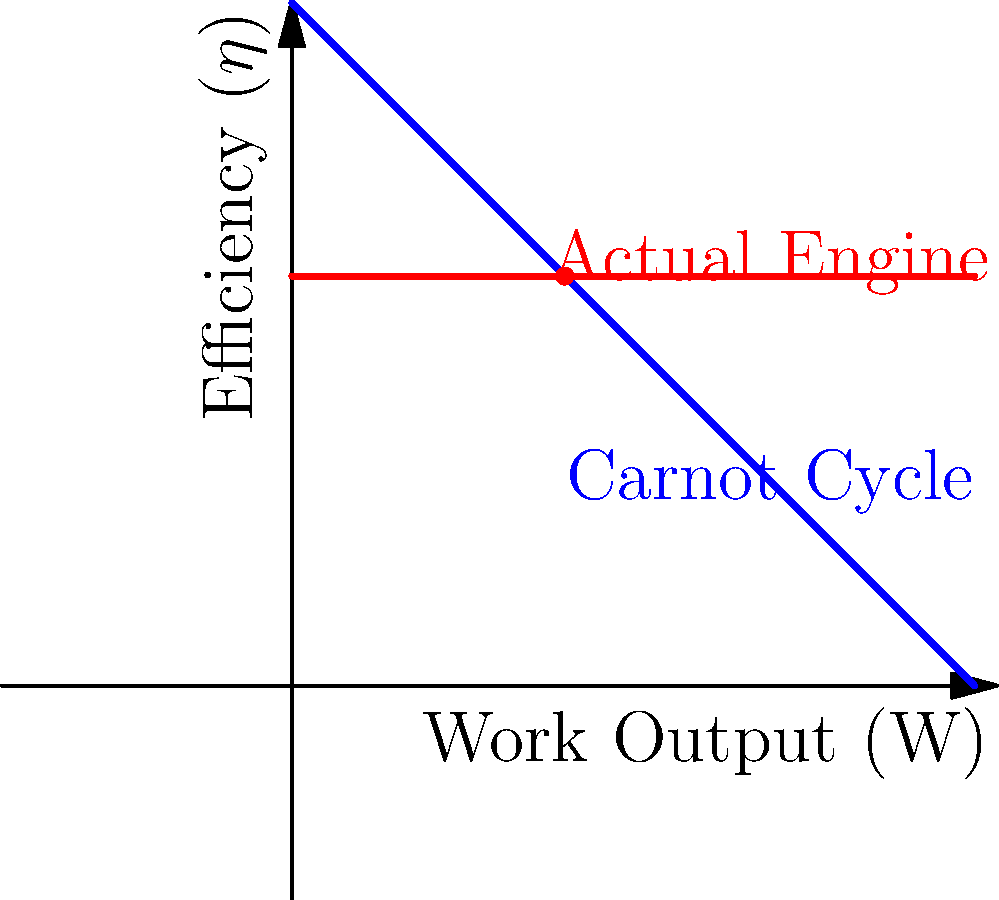In honor of Dame Kathleen Lonsdale, a pioneering woman in crystallography who contributed to our understanding of thermodynamics, consider a heat engine operating between temperatures of 400 K and 100 K. If this engine produces 200 kJ of work while rejecting 300 kJ of heat, what percentage of the Carnot efficiency does it achieve? Refer to the graph, where the blue line represents the Carnot cycle and the red line represents the actual engine efficiency. Let's approach this step-by-step:

1) First, we need to calculate the efficiency of our actual engine:
   $\eta_{actual} = \frac{W_{out}}{Q_{in}} = \frac{W_{out}}{Q_{in} + W_{out}}$
   
   $W_{out} = 200 \text{ kJ}$, $Q_{out} = 300 \text{ kJ}$
   
   $Q_{in} = Q_{out} + W_{out} = 300 + 200 = 500 \text{ kJ}$
   
   $\eta_{actual} = \frac{200}{500} = 0.4 \text{ or } 40\%$

2) Now, let's calculate the Carnot efficiency:
   $\eta_{Carnot} = 1 - \frac{T_C}{T_H} = 1 - \frac{100}{400} = 0.75 \text{ or } 75\%$

3) To find what percentage of Carnot efficiency our engine achieves:
   $\text{Percentage} = \frac{\eta_{actual}}{\eta_{Carnot}} \times 100\%$
   
   $= \frac{0.4}{0.75} \times 100\% = 53.33\%$

This matches the graph, where we can see the actual engine (red dot) achieving about 60% efficiency when the Carnot efficiency (blue line) is at 100%.
Answer: 53.33% 